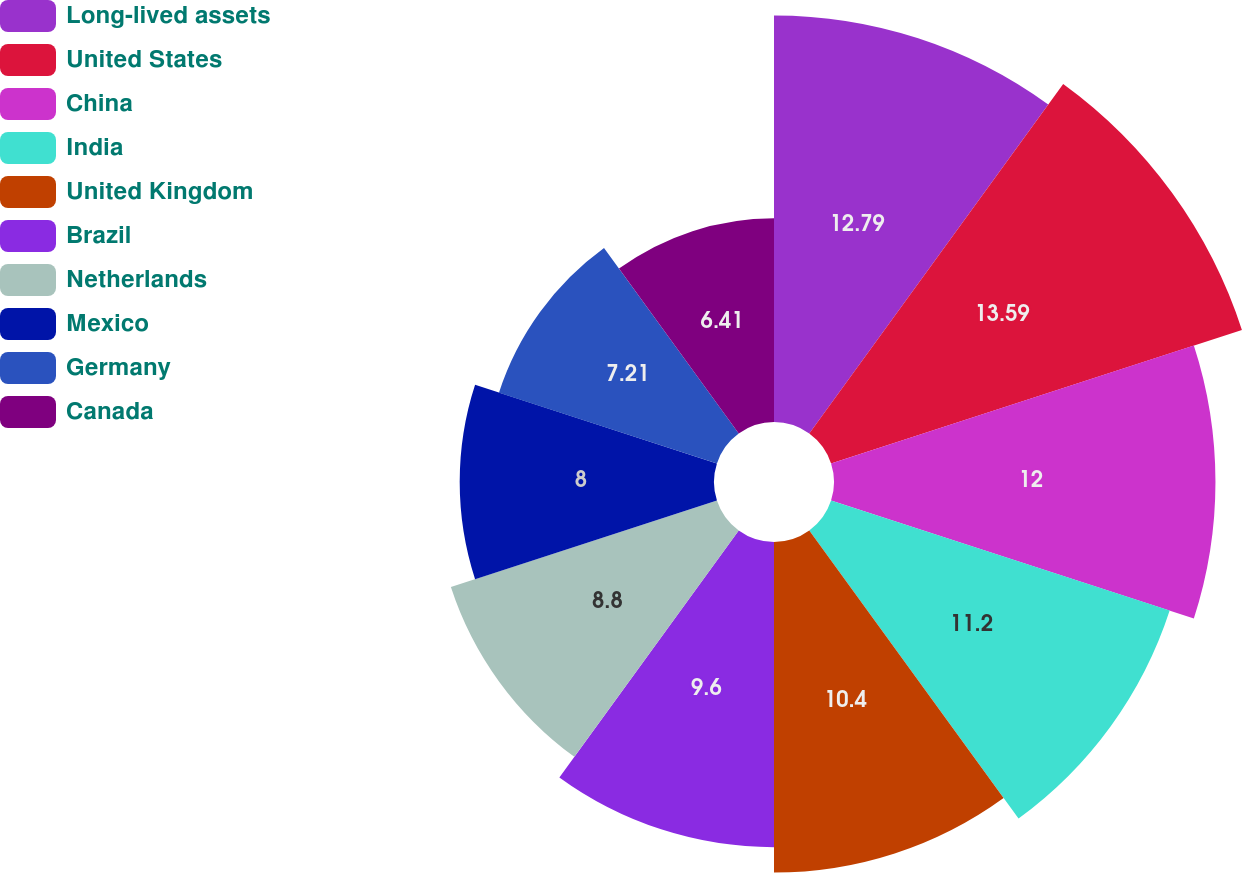Convert chart to OTSL. <chart><loc_0><loc_0><loc_500><loc_500><pie_chart><fcel>Long-lived assets<fcel>United States<fcel>China<fcel>India<fcel>United Kingdom<fcel>Brazil<fcel>Netherlands<fcel>Mexico<fcel>Germany<fcel>Canada<nl><fcel>12.79%<fcel>13.59%<fcel>12.0%<fcel>11.2%<fcel>10.4%<fcel>9.6%<fcel>8.8%<fcel>8.0%<fcel>7.21%<fcel>6.41%<nl></chart> 